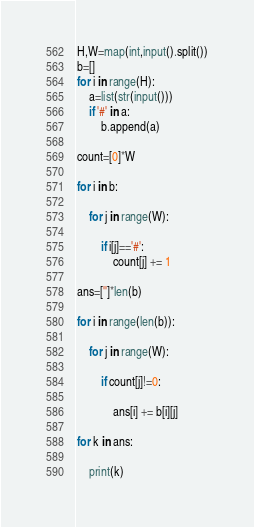<code> <loc_0><loc_0><loc_500><loc_500><_Python_>H,W=map(int,input().split())
b=[]
for i in range(H):
    a=list(str(input()))
    if '#' in a:
        b.append(a)

count=[0]*W

for i in b:

    for j in range(W):

        if i[j]=='#':
            count[j] += 1

ans=['']*len(b)

for i in range(len(b)):

    for j in range(W):

        if count[j]!=0:
            
            ans[i] += b[i][j]

for k in ans:

    print(k)


</code> 